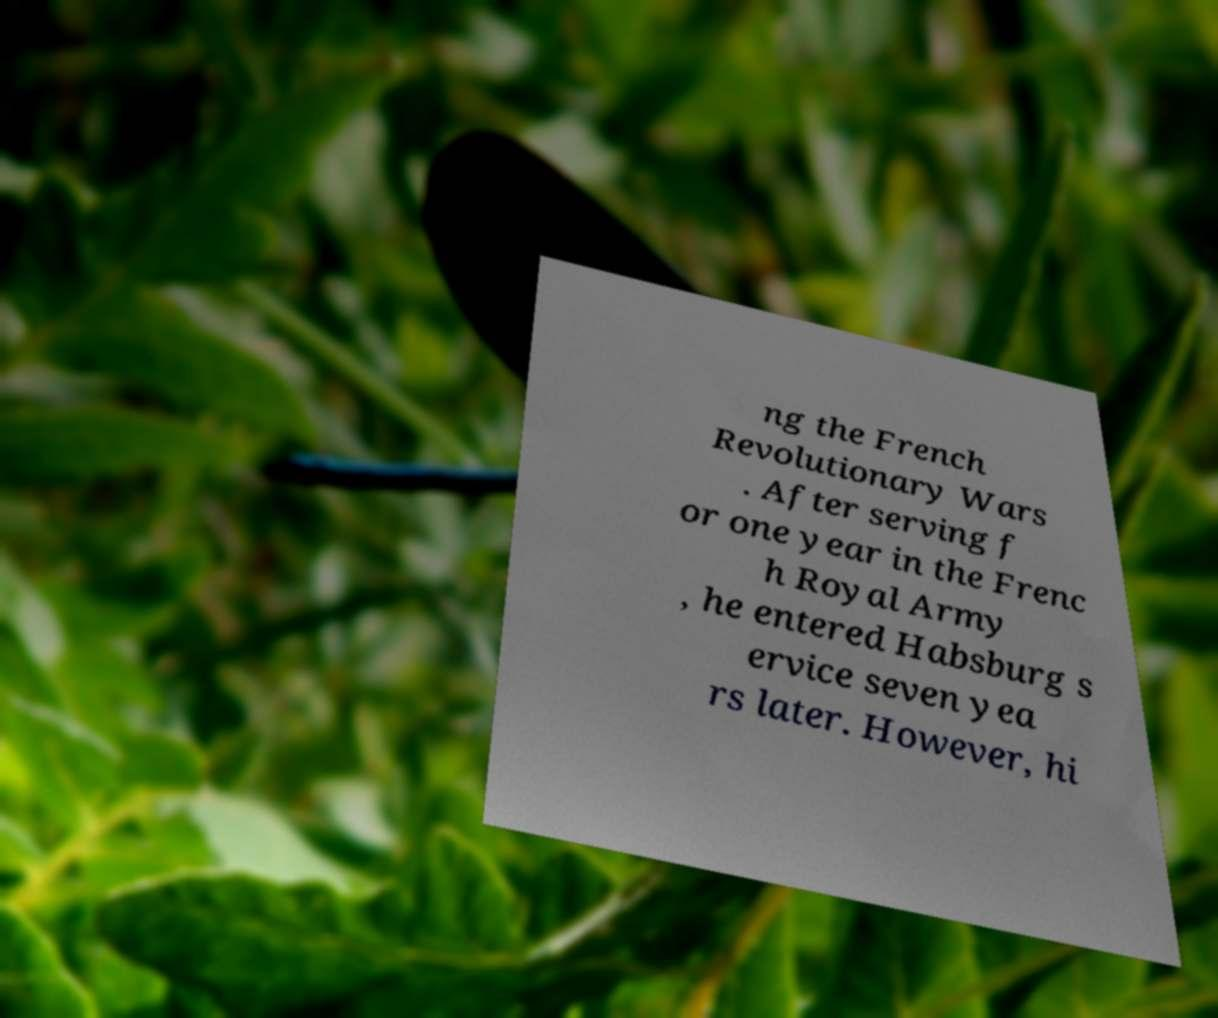I need the written content from this picture converted into text. Can you do that? ng the French Revolutionary Wars . After serving f or one year in the Frenc h Royal Army , he entered Habsburg s ervice seven yea rs later. However, hi 